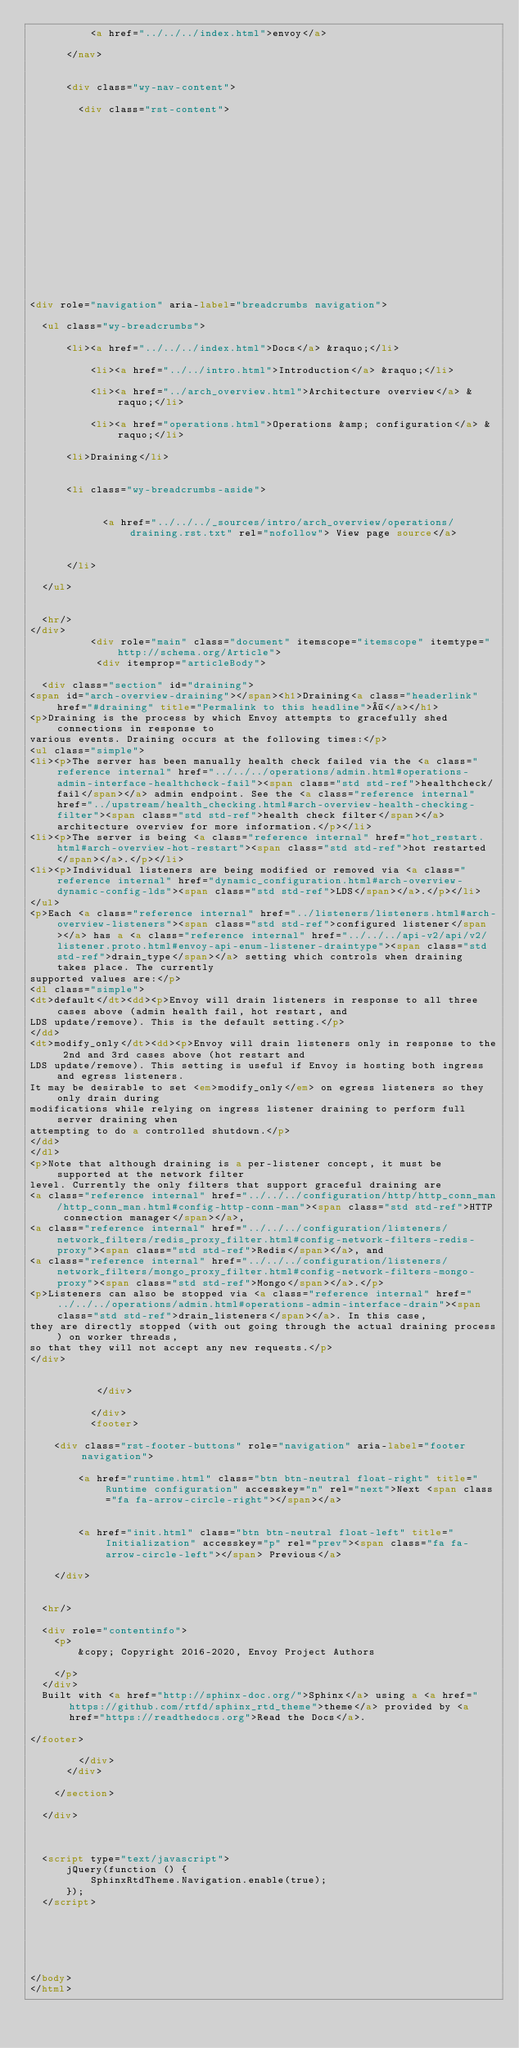Convert code to text. <code><loc_0><loc_0><loc_500><loc_500><_HTML_>          <a href="../../../index.html">envoy</a>
        
      </nav>


      <div class="wy-nav-content">
        
        <div class="rst-content">
        
          















<div role="navigation" aria-label="breadcrumbs navigation">

  <ul class="wy-breadcrumbs">
    
      <li><a href="../../../index.html">Docs</a> &raquo;</li>
        
          <li><a href="../../intro.html">Introduction</a> &raquo;</li>
        
          <li><a href="../arch_overview.html">Architecture overview</a> &raquo;</li>
        
          <li><a href="operations.html">Operations &amp; configuration</a> &raquo;</li>
        
      <li>Draining</li>
    
    
      <li class="wy-breadcrumbs-aside">
        
            
            <a href="../../../_sources/intro/arch_overview/operations/draining.rst.txt" rel="nofollow"> View page source</a>
          
        
      </li>
    
  </ul>

  
  <hr/>
</div>
          <div role="main" class="document" itemscope="itemscope" itemtype="http://schema.org/Article">
           <div itemprop="articleBody">
            
  <div class="section" id="draining">
<span id="arch-overview-draining"></span><h1>Draining<a class="headerlink" href="#draining" title="Permalink to this headline">¶</a></h1>
<p>Draining is the process by which Envoy attempts to gracefully shed connections in response to
various events. Draining occurs at the following times:</p>
<ul class="simple">
<li><p>The server has been manually health check failed via the <a class="reference internal" href="../../../operations/admin.html#operations-admin-interface-healthcheck-fail"><span class="std std-ref">healthcheck/fail</span></a> admin endpoint. See the <a class="reference internal" href="../upstream/health_checking.html#arch-overview-health-checking-filter"><span class="std std-ref">health check filter</span></a> architecture overview for more information.</p></li>
<li><p>The server is being <a class="reference internal" href="hot_restart.html#arch-overview-hot-restart"><span class="std std-ref">hot restarted</span></a>.</p></li>
<li><p>Individual listeners are being modified or removed via <a class="reference internal" href="dynamic_configuration.html#arch-overview-dynamic-config-lds"><span class="std std-ref">LDS</span></a>.</p></li>
</ul>
<p>Each <a class="reference internal" href="../listeners/listeners.html#arch-overview-listeners"><span class="std std-ref">configured listener</span></a> has a <a class="reference internal" href="../../../api-v2/api/v2/listener.proto.html#envoy-api-enum-listener-draintype"><span class="std std-ref">drain_type</span></a> setting which controls when draining takes place. The currently
supported values are:</p>
<dl class="simple">
<dt>default</dt><dd><p>Envoy will drain listeners in response to all three cases above (admin health fail, hot restart, and
LDS update/remove). This is the default setting.</p>
</dd>
<dt>modify_only</dt><dd><p>Envoy will drain listeners only in response to the 2nd and 3rd cases above (hot restart and
LDS update/remove). This setting is useful if Envoy is hosting both ingress and egress listeners.
It may be desirable to set <em>modify_only</em> on egress listeners so they only drain during
modifications while relying on ingress listener draining to perform full server draining when
attempting to do a controlled shutdown.</p>
</dd>
</dl>
<p>Note that although draining is a per-listener concept, it must be supported at the network filter
level. Currently the only filters that support graceful draining are
<a class="reference internal" href="../../../configuration/http/http_conn_man/http_conn_man.html#config-http-conn-man"><span class="std std-ref">HTTP connection manager</span></a>,
<a class="reference internal" href="../../../configuration/listeners/network_filters/redis_proxy_filter.html#config-network-filters-redis-proxy"><span class="std std-ref">Redis</span></a>, and
<a class="reference internal" href="../../../configuration/listeners/network_filters/mongo_proxy_filter.html#config-network-filters-mongo-proxy"><span class="std std-ref">Mongo</span></a>.</p>
<p>Listeners can also be stopped via <a class="reference internal" href="../../../operations/admin.html#operations-admin-interface-drain"><span class="std std-ref">drain_listeners</span></a>. In this case,
they are directly stopped (with out going through the actual draining process) on worker threads,
so that they will not accept any new requests.</p>
</div>


           </div>
           
          </div>
          <footer>
  
    <div class="rst-footer-buttons" role="navigation" aria-label="footer navigation">
      
        <a href="runtime.html" class="btn btn-neutral float-right" title="Runtime configuration" accesskey="n" rel="next">Next <span class="fa fa-arrow-circle-right"></span></a>
      
      
        <a href="init.html" class="btn btn-neutral float-left" title="Initialization" accesskey="p" rel="prev"><span class="fa fa-arrow-circle-left"></span> Previous</a>
      
    </div>
  

  <hr/>

  <div role="contentinfo">
    <p>
        &copy; Copyright 2016-2020, Envoy Project Authors

    </p>
  </div>
  Built with <a href="http://sphinx-doc.org/">Sphinx</a> using a <a href="https://github.com/rtfd/sphinx_rtd_theme">theme</a> provided by <a href="https://readthedocs.org">Read the Docs</a>. 

</footer>

        </div>
      </div>

    </section>

  </div>
  


  <script type="text/javascript">
      jQuery(function () {
          SphinxRtdTheme.Navigation.enable(true);
      });
  </script>

  
  
    
   

</body>
</html></code> 